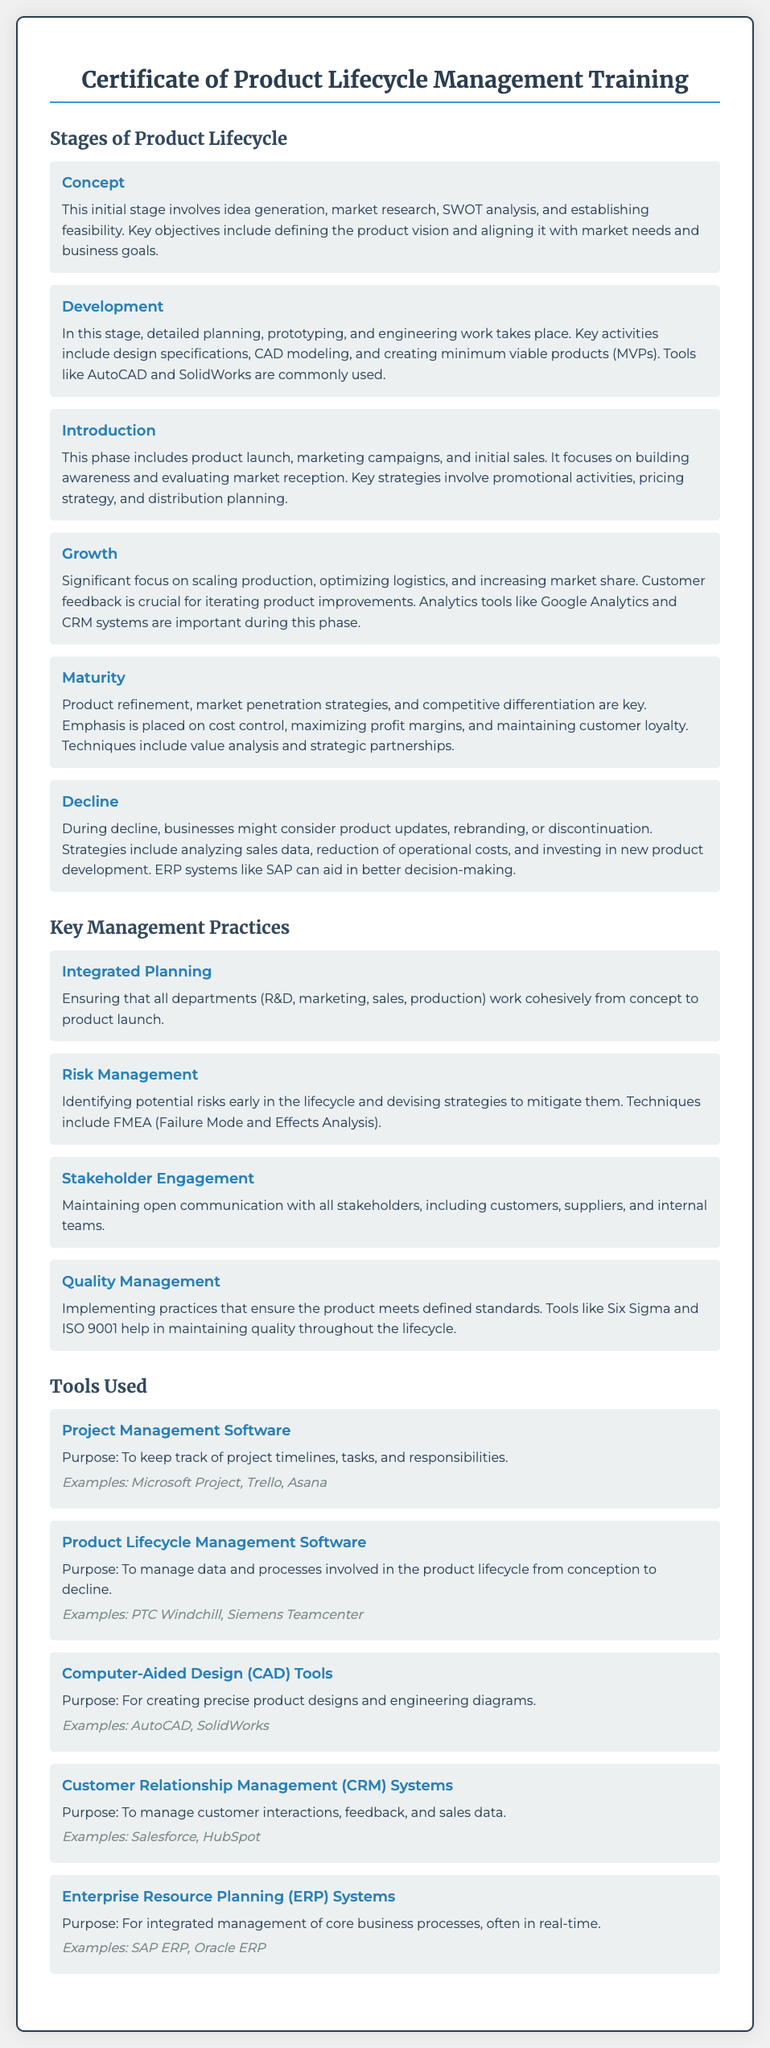what is the first stage of the product lifecycle? The first stage is outlined in the document as "Concept."
Answer: Concept which tool is used for project management? The document lists specific software for project management, such as "Microsoft Project."
Answer: Microsoft Project what is an important focus during the Growth stage? The Growth stage emphasizes "increasing market share."
Answer: increasing market share how many key management practices are mentioned? The document mentions four key management practices.
Answer: four what purpose does ERP software serve? The document states that ERP systems are used for "integrated management of core business processes."
Answer: integrated management of core business processes what does the Development stage include? The Development stage includes "detailed planning, prototyping, and engineering work."
Answer: detailed planning, prototyping, and engineering work which tool is related to managing customer interactions? The relevant tool for managing customer interactions, according to the document, is "CRM systems."
Answer: CRM systems what is a technique included in Risk Management? The document mentions "FMEA" as a technique in Risk Management.
Answer: FMEA name a software used for CAD. The document lists "AutoCAD" as an example of CAD software.
Answer: AutoCAD 